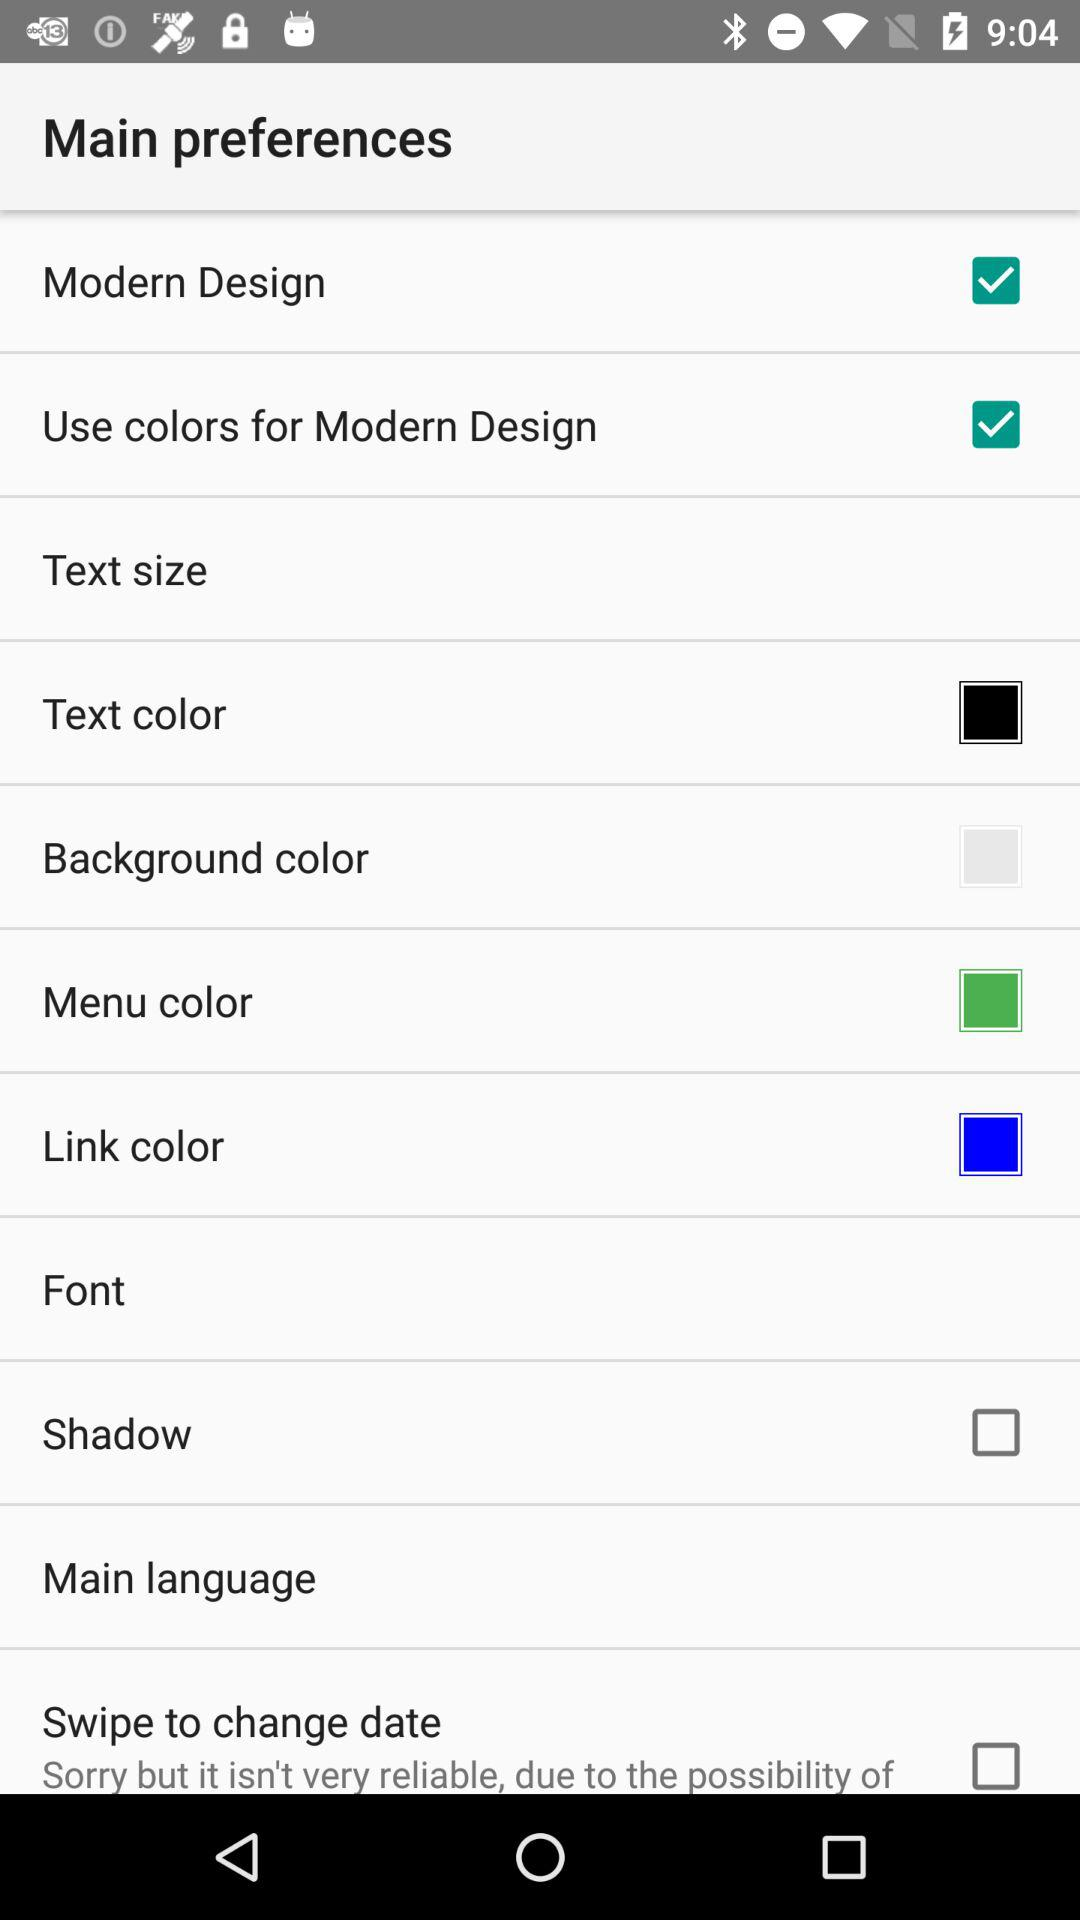What is the status of the "Modern Design"? The status is "on". 